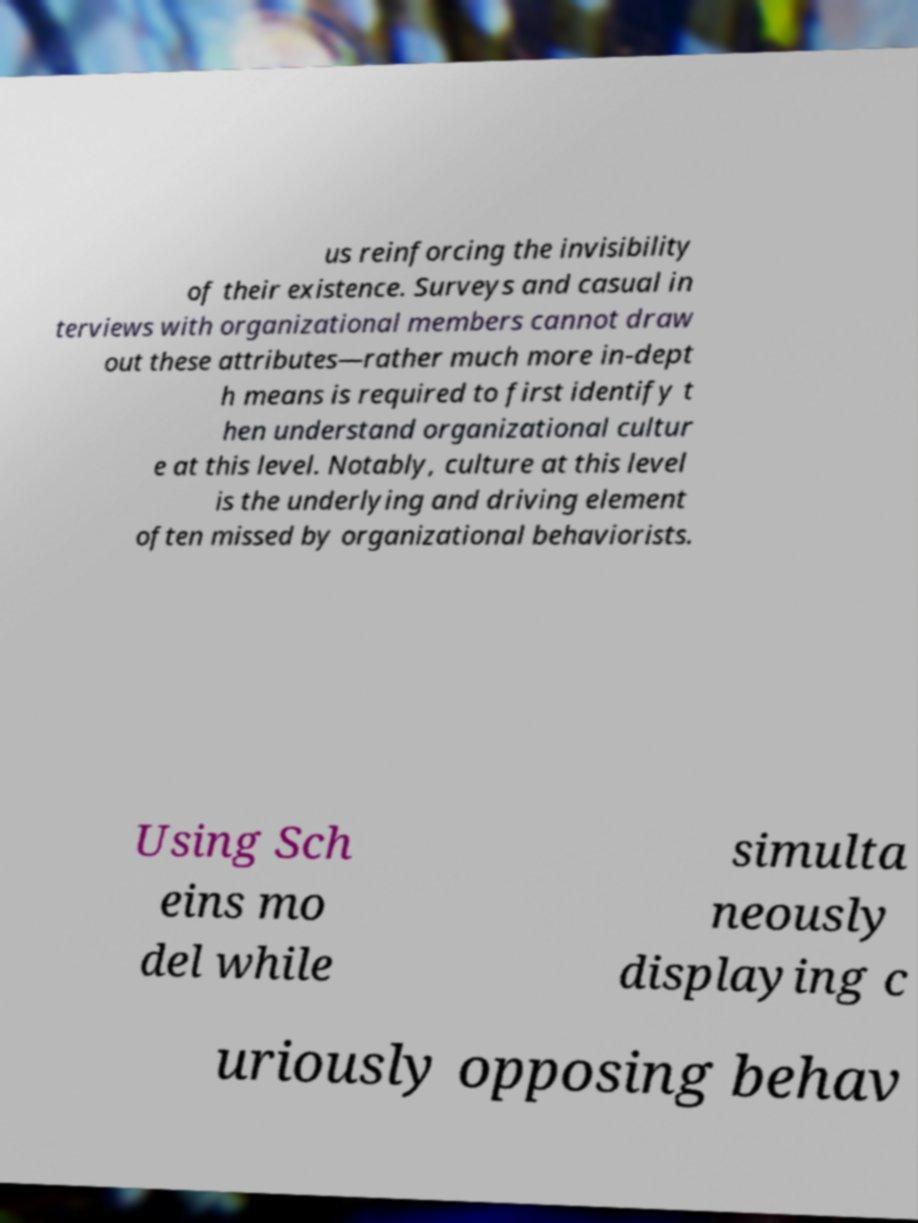There's text embedded in this image that I need extracted. Can you transcribe it verbatim? us reinforcing the invisibility of their existence. Surveys and casual in terviews with organizational members cannot draw out these attributes—rather much more in-dept h means is required to first identify t hen understand organizational cultur e at this level. Notably, culture at this level is the underlying and driving element often missed by organizational behaviorists. Using Sch eins mo del while simulta neously displaying c uriously opposing behav 